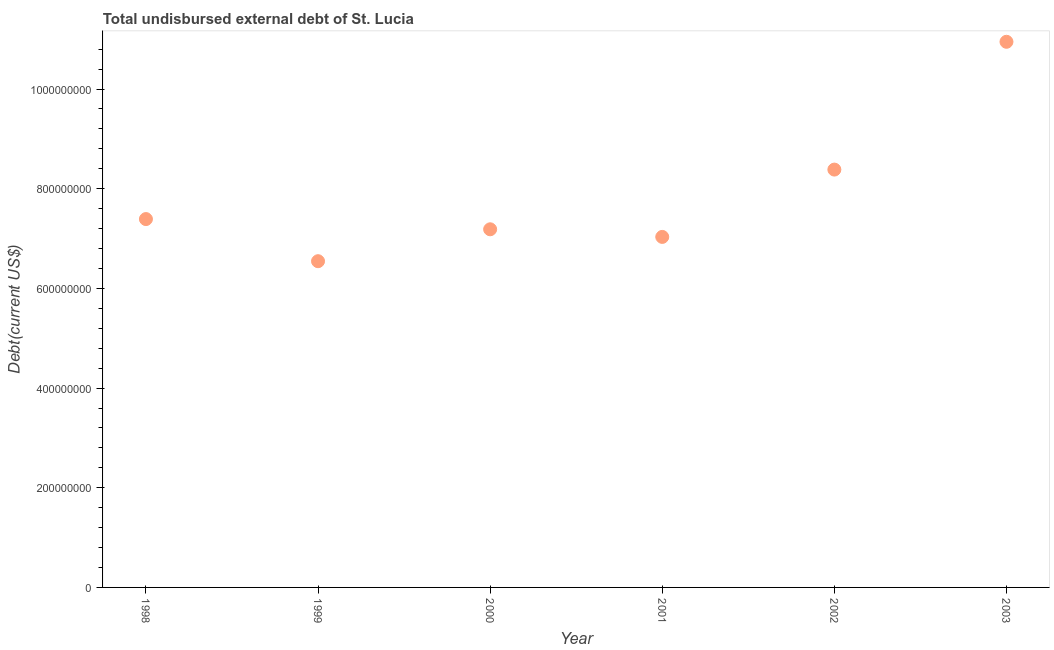What is the total debt in 1999?
Give a very brief answer. 6.55e+08. Across all years, what is the maximum total debt?
Keep it short and to the point. 1.09e+09. Across all years, what is the minimum total debt?
Your answer should be very brief. 6.55e+08. In which year was the total debt maximum?
Make the answer very short. 2003. In which year was the total debt minimum?
Give a very brief answer. 1999. What is the sum of the total debt?
Provide a short and direct response. 4.75e+09. What is the difference between the total debt in 1998 and 2002?
Keep it short and to the point. -9.93e+07. What is the average total debt per year?
Offer a very short reply. 7.91e+08. What is the median total debt?
Your response must be concise. 7.29e+08. In how many years, is the total debt greater than 80000000 US$?
Give a very brief answer. 6. Do a majority of the years between 2001 and 1999 (inclusive) have total debt greater than 1040000000 US$?
Your answer should be compact. No. What is the ratio of the total debt in 2000 to that in 2001?
Offer a very short reply. 1.02. Is the difference between the total debt in 1999 and 2000 greater than the difference between any two years?
Keep it short and to the point. No. What is the difference between the highest and the second highest total debt?
Make the answer very short. 2.56e+08. What is the difference between the highest and the lowest total debt?
Offer a terse response. 4.40e+08. Does the total debt monotonically increase over the years?
Your answer should be very brief. No. How many dotlines are there?
Provide a short and direct response. 1. How many years are there in the graph?
Your answer should be very brief. 6. Are the values on the major ticks of Y-axis written in scientific E-notation?
Give a very brief answer. No. Does the graph contain any zero values?
Offer a very short reply. No. What is the title of the graph?
Your answer should be compact. Total undisbursed external debt of St. Lucia. What is the label or title of the X-axis?
Your response must be concise. Year. What is the label or title of the Y-axis?
Provide a short and direct response. Debt(current US$). What is the Debt(current US$) in 1998?
Provide a short and direct response. 7.39e+08. What is the Debt(current US$) in 1999?
Offer a very short reply. 6.55e+08. What is the Debt(current US$) in 2000?
Provide a succinct answer. 7.19e+08. What is the Debt(current US$) in 2001?
Give a very brief answer. 7.03e+08. What is the Debt(current US$) in 2002?
Provide a succinct answer. 8.38e+08. What is the Debt(current US$) in 2003?
Your answer should be very brief. 1.09e+09. What is the difference between the Debt(current US$) in 1998 and 1999?
Give a very brief answer. 8.45e+07. What is the difference between the Debt(current US$) in 1998 and 2000?
Provide a succinct answer. 2.05e+07. What is the difference between the Debt(current US$) in 1998 and 2001?
Provide a succinct answer. 3.58e+07. What is the difference between the Debt(current US$) in 1998 and 2002?
Offer a very short reply. -9.93e+07. What is the difference between the Debt(current US$) in 1998 and 2003?
Provide a short and direct response. -3.56e+08. What is the difference between the Debt(current US$) in 1999 and 2000?
Offer a very short reply. -6.40e+07. What is the difference between the Debt(current US$) in 1999 and 2001?
Ensure brevity in your answer.  -4.87e+07. What is the difference between the Debt(current US$) in 1999 and 2002?
Provide a short and direct response. -1.84e+08. What is the difference between the Debt(current US$) in 1999 and 2003?
Give a very brief answer. -4.40e+08. What is the difference between the Debt(current US$) in 2000 and 2001?
Your answer should be compact. 1.53e+07. What is the difference between the Debt(current US$) in 2000 and 2002?
Give a very brief answer. -1.20e+08. What is the difference between the Debt(current US$) in 2000 and 2003?
Make the answer very short. -3.76e+08. What is the difference between the Debt(current US$) in 2001 and 2002?
Offer a terse response. -1.35e+08. What is the difference between the Debt(current US$) in 2001 and 2003?
Offer a very short reply. -3.91e+08. What is the difference between the Debt(current US$) in 2002 and 2003?
Offer a terse response. -2.56e+08. What is the ratio of the Debt(current US$) in 1998 to that in 1999?
Provide a succinct answer. 1.13. What is the ratio of the Debt(current US$) in 1998 to that in 2000?
Offer a terse response. 1.03. What is the ratio of the Debt(current US$) in 1998 to that in 2001?
Keep it short and to the point. 1.05. What is the ratio of the Debt(current US$) in 1998 to that in 2002?
Ensure brevity in your answer.  0.88. What is the ratio of the Debt(current US$) in 1998 to that in 2003?
Your answer should be very brief. 0.68. What is the ratio of the Debt(current US$) in 1999 to that in 2000?
Your answer should be compact. 0.91. What is the ratio of the Debt(current US$) in 1999 to that in 2001?
Give a very brief answer. 0.93. What is the ratio of the Debt(current US$) in 1999 to that in 2002?
Your answer should be compact. 0.78. What is the ratio of the Debt(current US$) in 1999 to that in 2003?
Your answer should be compact. 0.6. What is the ratio of the Debt(current US$) in 2000 to that in 2002?
Provide a short and direct response. 0.86. What is the ratio of the Debt(current US$) in 2000 to that in 2003?
Ensure brevity in your answer.  0.66. What is the ratio of the Debt(current US$) in 2001 to that in 2002?
Make the answer very short. 0.84. What is the ratio of the Debt(current US$) in 2001 to that in 2003?
Your answer should be compact. 0.64. What is the ratio of the Debt(current US$) in 2002 to that in 2003?
Keep it short and to the point. 0.77. 